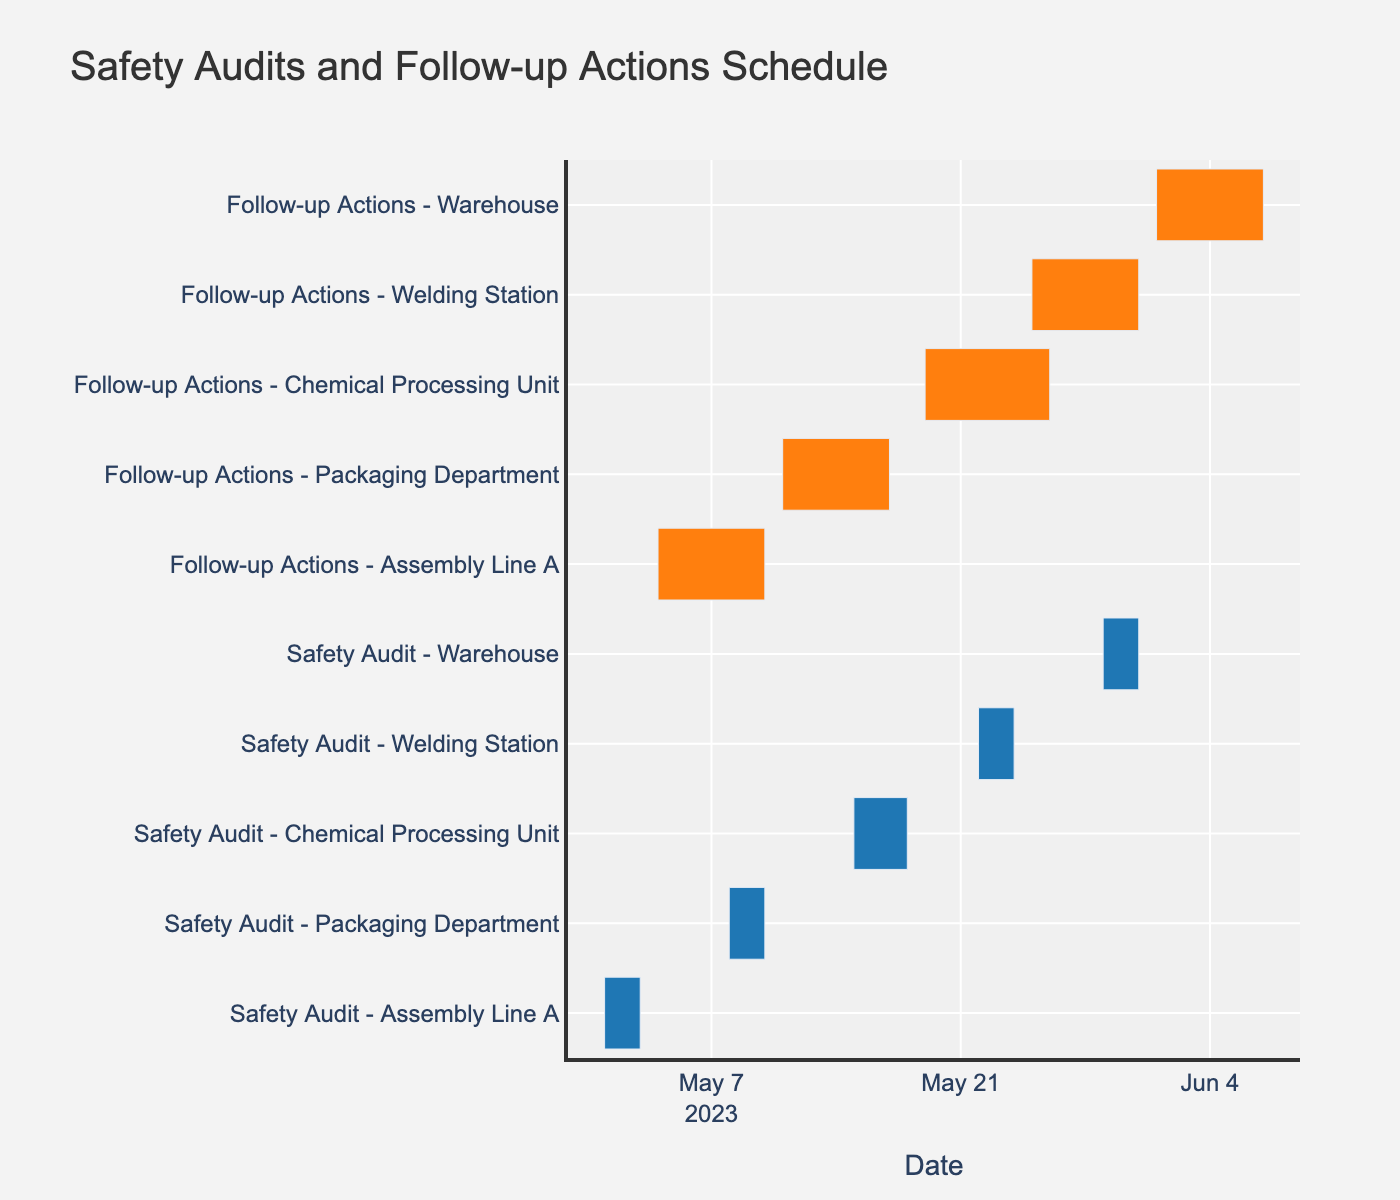What's the title of the figure? The title of the figure is usually displayed at the top of the chart, which is "Safety Audits and Follow-up Actions Schedule".
Answer: Safety Audits and Follow-up Actions Schedule What is the duration of the Follow-up Actions for the Packaging Department? First, locate the row corresponding to the follow-up actions for the Packaging Department. The duration is mentioned as 7 days.
Answer: 7 days How many total days are spent on Safety Audits for all production lines combined? Sum the durations of all safety audits: 3 (Assembly Line A) + 3 (Packaging Department) + 4 (Chemical Processing Unit) + 3 (Welding Station) + 3 (Warehouse) = 16 days.
Answer: 16 days Which production line has the longest Follow-up Actions period? First, look at the durations of follow-up actions for each production line: Assembly Line A (7), Packaging Department (7), Chemical Processing Unit (8), Welding Station (7), Warehouse (7). The longest duration is for the Chemical Processing Unit.
Answer: Chemical Processing Unit How many days after the Safety Audit in Assembly Line A does the Follow-up Action start? The Safety Audit in Assembly Line A ends on 2023-05-03, and the Follow-up Actions start on 2023-05-04. The difference is 1 day.
Answer: 1 day Which task starts first in the entire timeline and when does it start? The earliest start date in the data is 2023-05-01 for the Safety Audit of Assembly Line A.
Answer: Safety Audit - Assembly Line A on 2023-05-01 How does the duration of the Follow-up Actions for the Welding Station compare to that for the Assembly Line A? Both follow-up actions for the Welding Station and Assembly Line A have a duration of 7 days each.
Answer: Equal What is the total duration for both Safety Audit and Follow-up Actions combined for the Chemical Processing Unit? Add the durations for the safety audit (4 days) and follow-up actions (8 days) for the Chemical Processing Unit: 4 + 8 = 12 days.
Answer: 12 days 